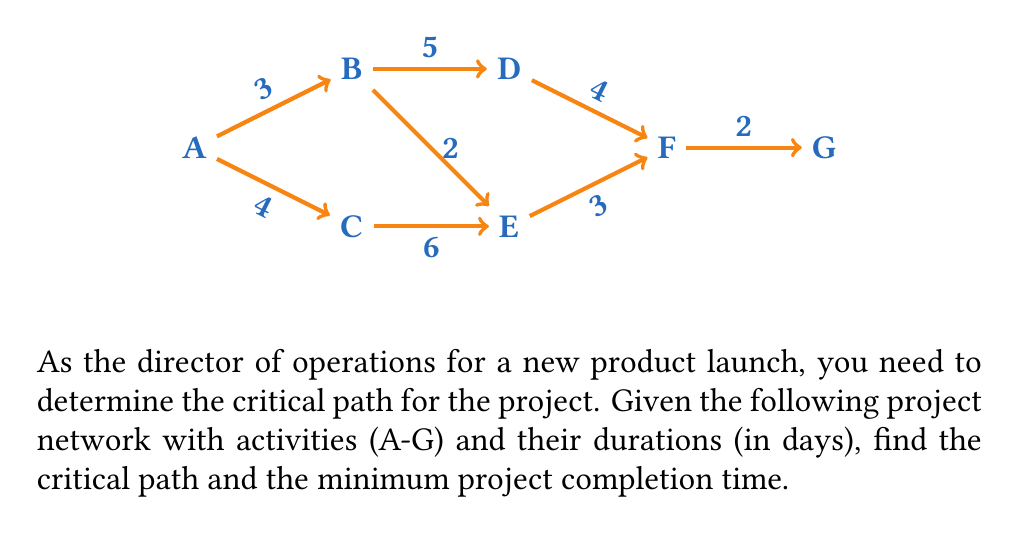Can you answer this question? To determine the critical path and minimum project completion time, we'll use the forward pass and backward pass methods:

1. Forward pass (earliest start times):
   - Start with node A at time 0
   - Calculate earliest finish time (EF) for each activity:
     $$EF = ES + Duration$$
   - Earliest start time (ES) for next activity is the maximum EF of all preceding activities

   A: ES = 0, EF = 0 + 3 = 3
   B: ES = 3, EF = 3 + 5 = 8
   C: ES = 0, EF = 0 + 4 = 4
   D: ES = 8, EF = 8 + 4 = 12
   E: ES = max(4, 3+2) = 5, EF = 5 + 3 = 8
   F: ES = max(12, 8) = 12, EF = 12 + 2 = 14
   G: ES = 14, EF = 14 + 0 = 14

2. Backward pass (latest finish times):
   - Start with node G at time 14
   - Calculate latest start time (LS) for each activity:
     $$LS = LF - Duration$$
   - Latest finish time (LF) for preceding activity is the minimum LS of all succeeding activities

   G: LF = 14, LS = 14 - 0 = 14
   F: LF = 14, LS = 14 - 2 = 12
   D: LF = 12, LS = 12 - 4 = 8
   E: LF = 12, LS = 12 - 3 = 9
   B: LF = min(8, 9) = 8, LS = 8 - 5 = 3
   C: LF = 9, LS = 9 - 6 = 3
   A: LF = min(3, 3) = 3, LS = 3 - 3 = 0

3. Calculate float (slack) for each activity:
   $$Float = LS - ES$$

   A: 0 - 0 = 0
   B: 3 - 3 = 0
   C: 3 - 0 = 3
   D: 8 - 8 = 0
   E: 9 - 5 = 4
   F: 12 - 12 = 0
   G: 14 - 14 = 0

4. Identify critical path:
   The critical path consists of activities with zero float:
   A → B → D → F → G

5. Minimum project completion time:
   The minimum completion time is the EF of the last activity (G), which is 14 days.
Answer: Critical Path: A → B → D → F → G
Minimum Project Completion Time: 14 days 